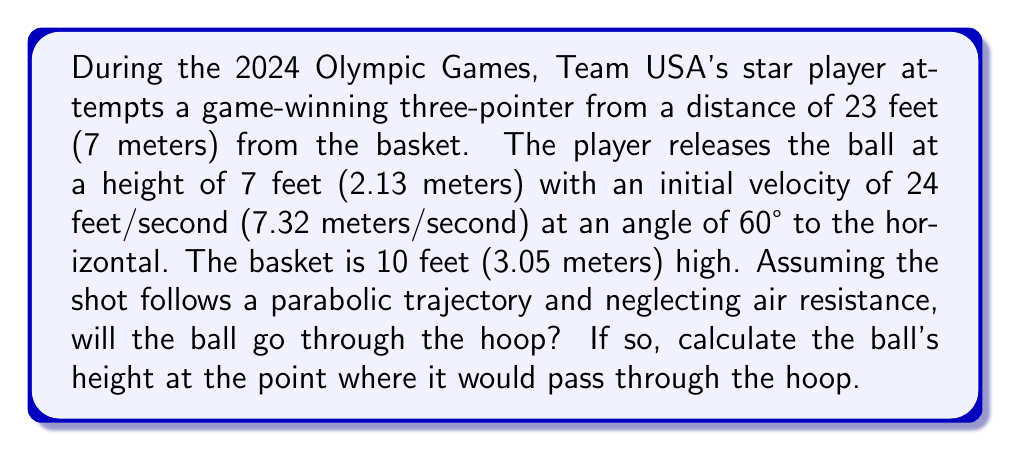Could you help me with this problem? Let's approach this step-by-step using the parabolic equation for projectile motion:

1) The general equation for a parabola in projectile motion is:
   $$y = -\frac{gx^2}{2(v_0\cos\theta)^2} + (x\tan\theta) + y_0$$
   Where $g$ is acceleration due to gravity (9.8 m/s²), $v_0$ is initial velocity, $\theta$ is the launch angle, and $y_0$ is the initial height.

2) We're given:
   - $v_0 = 7.32$ m/s
   - $\theta = 60°$
   - $y_0 = 2.13$ m
   - Basket is at $x = 7$ m and $y = 3.05$ m

3) Let's substitute these values into our equation:
   $$y = -\frac{9.8x^2}{2(7.32\cos60°)^2} + (x\tan60°) + 2.13$$

4) Simplify:
   $$y = -0.464x^2 + 1.732x + 2.13$$

5) To find if the ball goes through the hoop, we need to calculate y when x = 7:
   $$y = -0.464(7)^2 + 1.732(7) + 2.13$$
   $$y = -22.736 + 12.124 + 2.13$$
   $$y = -8.482 + 2.13 = -6.352$$

6) The height of the ball at x = 7 m is -6.352 + 2.13 = -4.222 m

7) Since -4.222 m is below the height of the basket (3.05 m), the ball will not go through the hoop.
Answer: The ball will not go through the hoop. At the point where it would reach the basket horizontally (7 meters from the release point), its height would be approximately -4.222 meters, which is below the ground level and well below the basket height of 3.05 meters. 